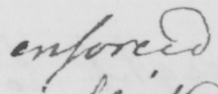Can you tell me what this handwritten text says? enforced 